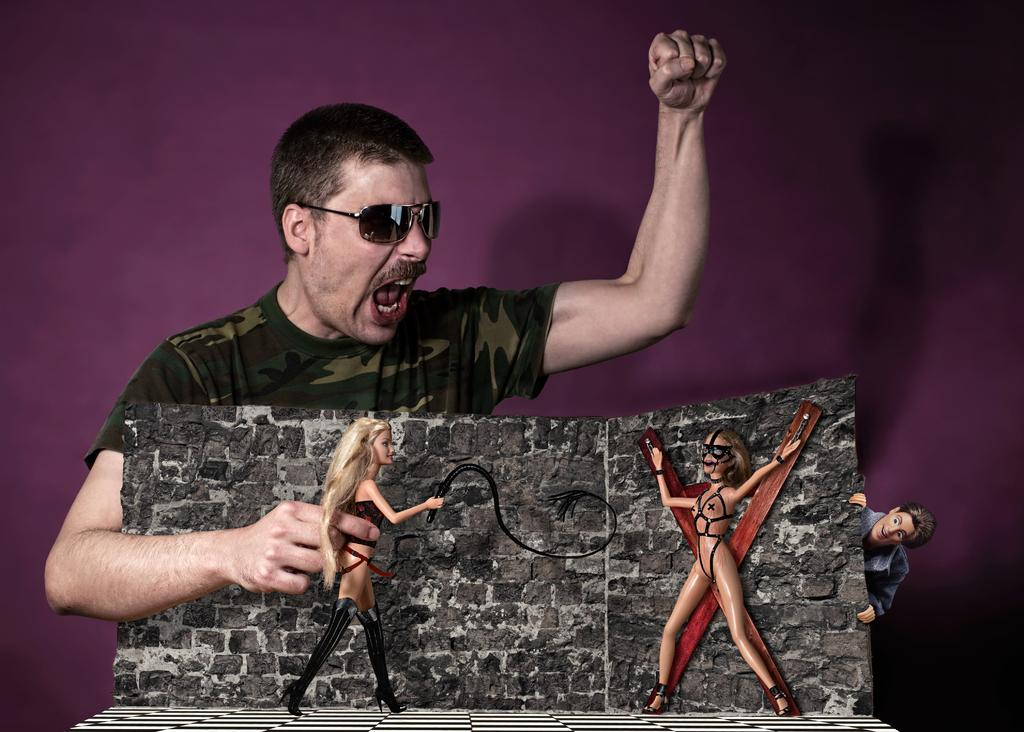What objects can be seen in the front of the image? There are toys in the front of the image. Where is the man located in the image? The man is standing in the center of the image. What is the man holding in the image? The man is holding a toy. How does the man transport the toys in the image? The image does not show the man transporting the toys; he is simply holding one toy. What type of thrill can be experienced by the toys in the image? The toys in the image are not experiencing any thrill; they are stationary and not engaged in any activity. 